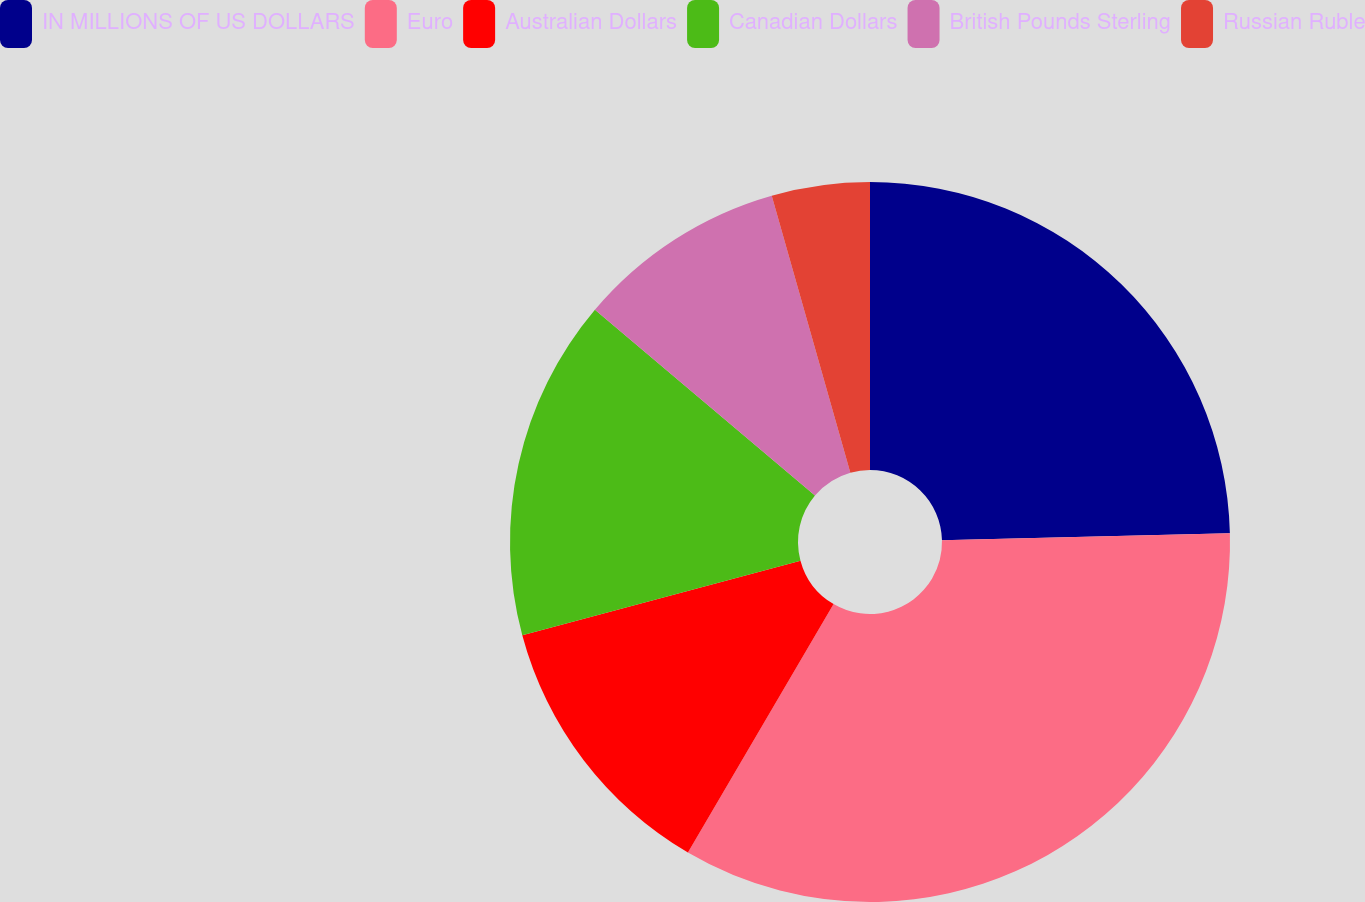Convert chart. <chart><loc_0><loc_0><loc_500><loc_500><pie_chart><fcel>IN MILLIONS OF US DOLLARS<fcel>Euro<fcel>Australian Dollars<fcel>Canadian Dollars<fcel>British Pounds Sterling<fcel>Russian Ruble<nl><fcel>24.61%<fcel>33.83%<fcel>12.39%<fcel>15.33%<fcel>9.44%<fcel>4.4%<nl></chart> 